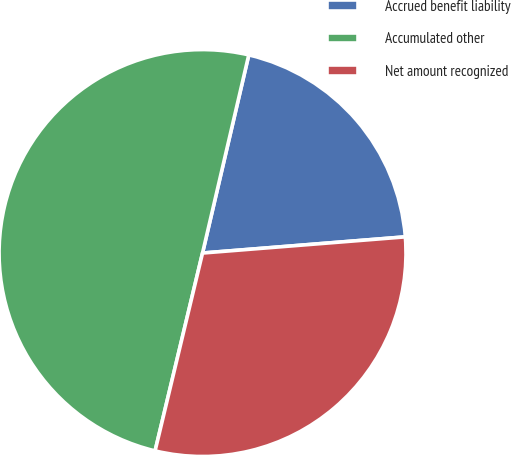<chart> <loc_0><loc_0><loc_500><loc_500><pie_chart><fcel>Accrued benefit liability<fcel>Accumulated other<fcel>Net amount recognized<nl><fcel>20.08%<fcel>49.9%<fcel>30.01%<nl></chart> 